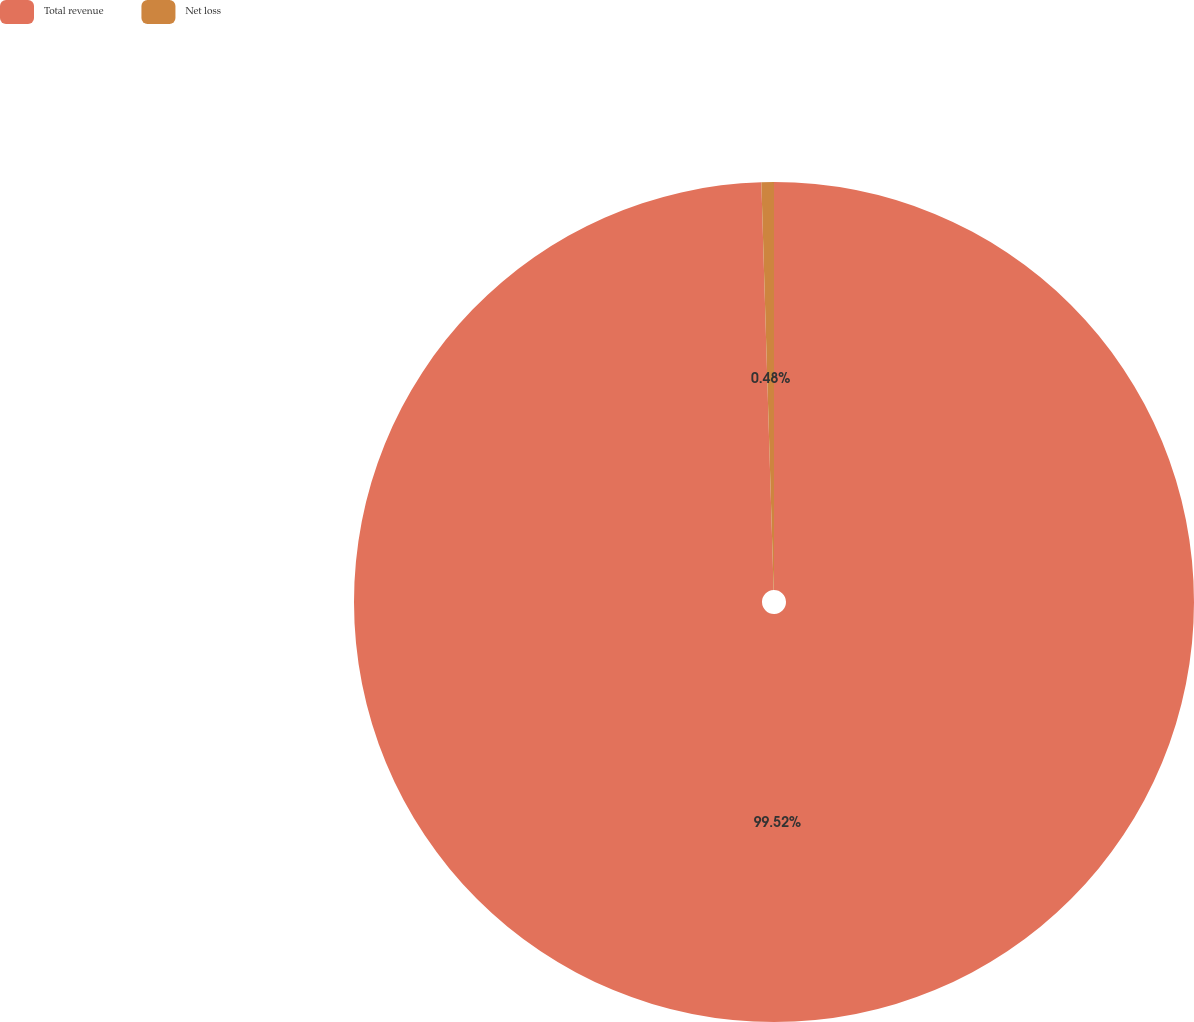Convert chart. <chart><loc_0><loc_0><loc_500><loc_500><pie_chart><fcel>Total revenue<fcel>Net loss<nl><fcel>99.52%<fcel>0.48%<nl></chart> 